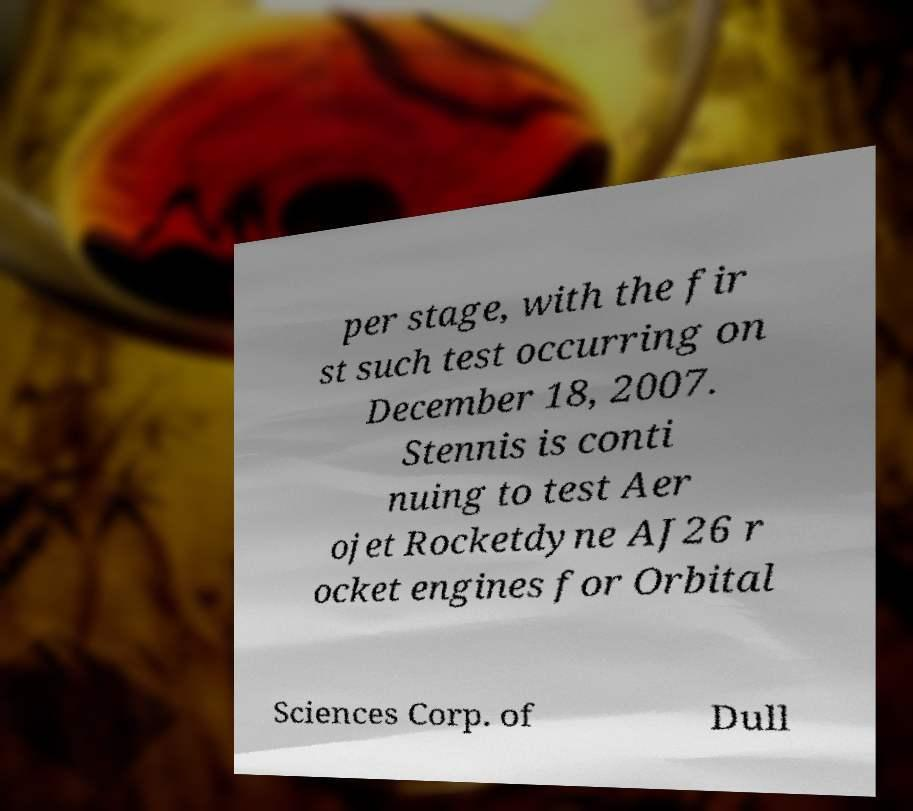I need the written content from this picture converted into text. Can you do that? per stage, with the fir st such test occurring on December 18, 2007. Stennis is conti nuing to test Aer ojet Rocketdyne AJ26 r ocket engines for Orbital Sciences Corp. of Dull 